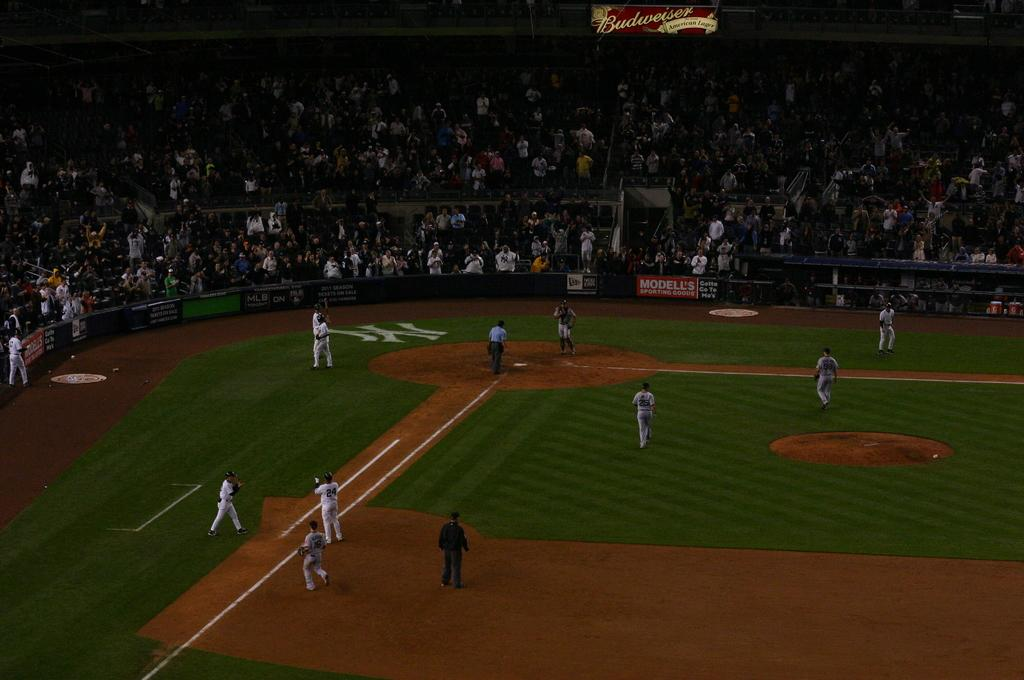Provide a one-sentence caption for the provided image. A baseball game being played on the NY Yankees field. 